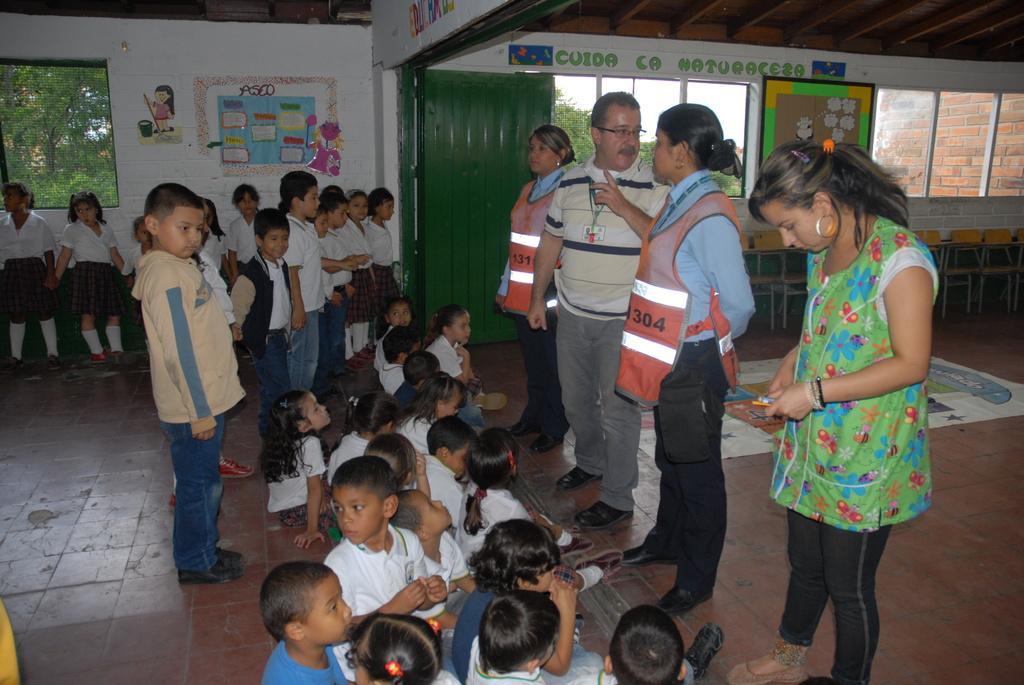Describe this image in one or two sentences. In this image I can see a group of people are sitting and few are standing on the floor. In the background I can see a wall, paintings, windows, trees and a door. This image is taken may be in a hall. 